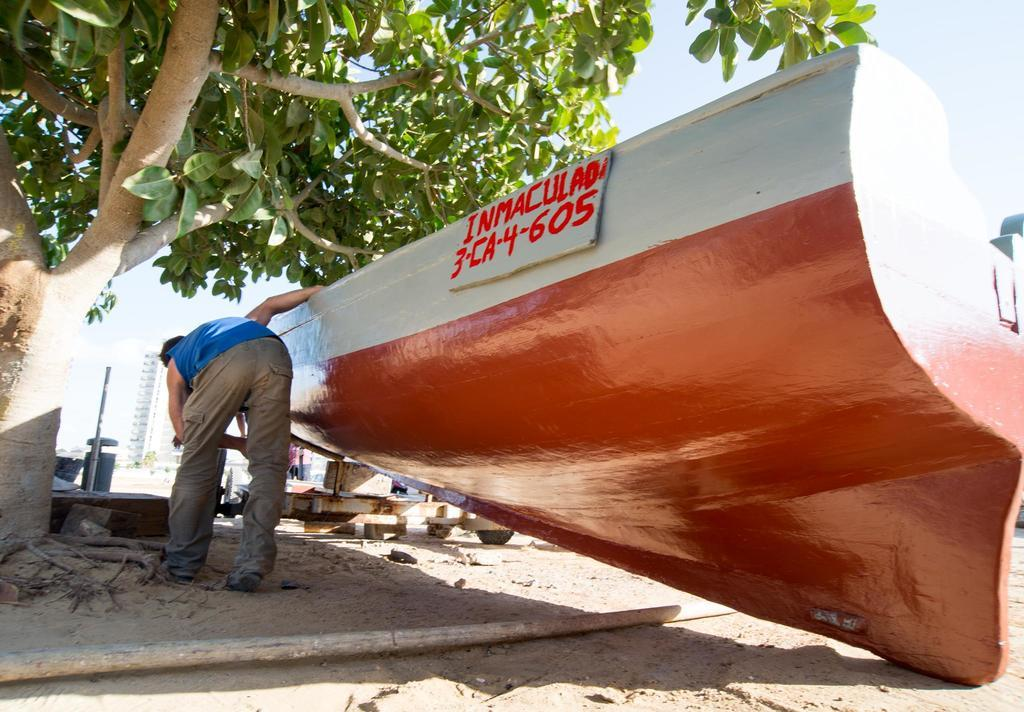What is the main object in the image? There is an object in the image, but the specific object is not mentioned in the facts. What can be seen near the object? There is a name board in the image. Who is present in the image? There is a person in the image. What type of vegetation is visible in the image? There is a tree in the image. What is lying on the ground in the image? There is a wooden stick on the ground in the image. What can be seen in the distance in the image? There are objects visible in the background of the image. What is visible in the sky in the image? The sky is visible in the background of the image. What type of wheel is being used in the competition in the image? There is no wheel or competition present in the image. What is the best way to reach the person in the image? The facts do not provide information about the location or accessibility of the person in the image, so it is not possible to determine the best way to reach them. 